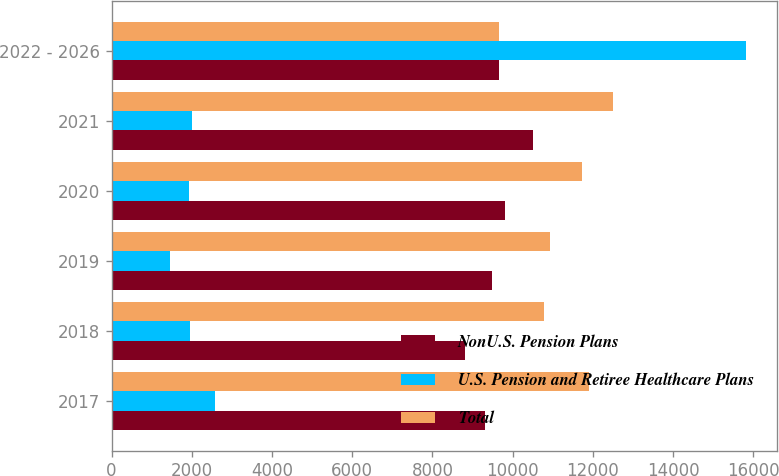Convert chart. <chart><loc_0><loc_0><loc_500><loc_500><stacked_bar_chart><ecel><fcel>2017<fcel>2018<fcel>2019<fcel>2020<fcel>2021<fcel>2022 - 2026<nl><fcel>NonU.S. Pension Plans<fcel>9318<fcel>8824<fcel>9480<fcel>9820<fcel>10504<fcel>9650<nl><fcel>U.S. Pension and Retiree Healthcare Plans<fcel>2579<fcel>1957<fcel>1459<fcel>1923<fcel>1994<fcel>15814<nl><fcel>Total<fcel>11897<fcel>10781<fcel>10939<fcel>11743<fcel>12498<fcel>9650<nl></chart> 